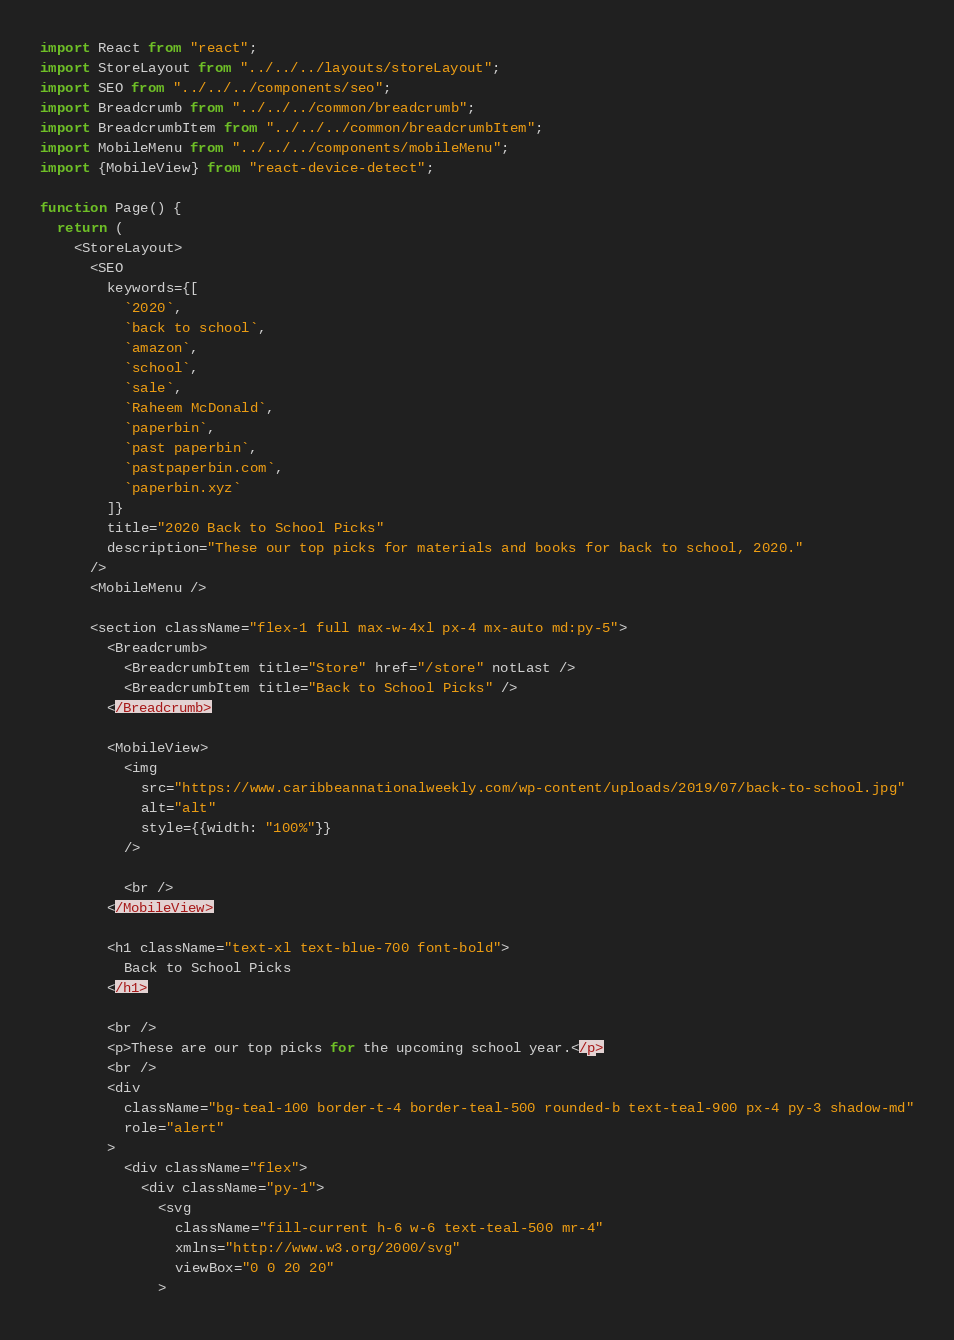Convert code to text. <code><loc_0><loc_0><loc_500><loc_500><_JavaScript_>import React from "react";
import StoreLayout from "../../../layouts/storeLayout";
import SEO from "../../../components/seo";
import Breadcrumb from "../../../common/breadcrumb";
import BreadcrumbItem from "../../../common/breadcrumbItem";
import MobileMenu from "../../../components/mobileMenu";
import {MobileView} from "react-device-detect";

function Page() {
  return (
    <StoreLayout>
      <SEO
        keywords={[
          `2020`,
          `back to school`,
          `amazon`,
          `school`,
          `sale`,
          `Raheem McDonald`,
          `paperbin`,
          `past paperbin`,
          `pastpaperbin.com`,
          `paperbin.xyz`
        ]}
        title="2020 Back to School Picks"
        description="These our top picks for materials and books for back to school, 2020."
      />
      <MobileMenu />

      <section className="flex-1 full max-w-4xl px-4 mx-auto md:py-5">
        <Breadcrumb>
          <BreadcrumbItem title="Store" href="/store" notLast />
          <BreadcrumbItem title="Back to School Picks" />
        </Breadcrumb>

        <MobileView>
          <img
            src="https://www.caribbeannationalweekly.com/wp-content/uploads/2019/07/back-to-school.jpg"
            alt="alt"
            style={{width: "100%"}}
          />

          <br />
        </MobileView>

        <h1 className="text-xl text-blue-700 font-bold">
          Back to School Picks
        </h1>

        <br />
        <p>These are our top picks for the upcoming school year.</p>
        <br />
        <div
          className="bg-teal-100 border-t-4 border-teal-500 rounded-b text-teal-900 px-4 py-3 shadow-md"
          role="alert"
        >
          <div className="flex">
            <div className="py-1">
              <svg
                className="fill-current h-6 w-6 text-teal-500 mr-4"
                xmlns="http://www.w3.org/2000/svg"
                viewBox="0 0 20 20"
              ></code> 